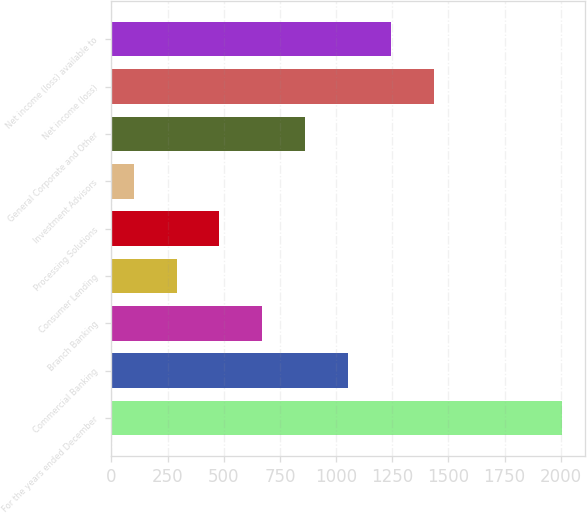<chart> <loc_0><loc_0><loc_500><loc_500><bar_chart><fcel>For the years ended December<fcel>Commercial Banking<fcel>Branch Banking<fcel>Consumer Lending<fcel>Processing Solutions<fcel>Investment Advisors<fcel>General Corporate and Other<fcel>Net income (loss)<fcel>Net income (loss) available to<nl><fcel>2007<fcel>1053<fcel>671.4<fcel>289.8<fcel>480.6<fcel>99<fcel>862.2<fcel>1434.6<fcel>1243.8<nl></chart> 